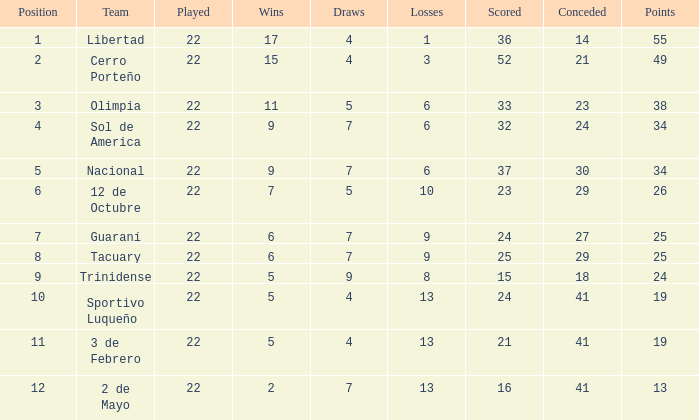How many draws does the team have if they have over 8 losses and 13 points? 7.0. 